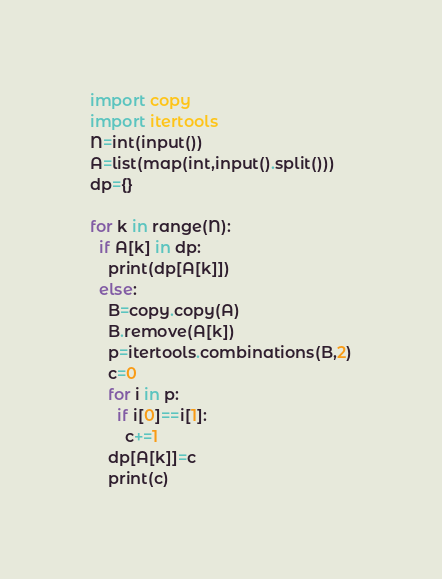Convert code to text. <code><loc_0><loc_0><loc_500><loc_500><_Python_>import copy
import itertools
N=int(input())
A=list(map(int,input().split()))
dp={}

for k in range(N):
  if A[k] in dp:
    print(dp[A[k]])
  else:
    B=copy.copy(A)
    B.remove(A[k])
    p=itertools.combinations(B,2)
    c=0
    for i in p:
      if i[0]==i[1]:
        c+=1
    dp[A[k]]=c
    print(c)</code> 